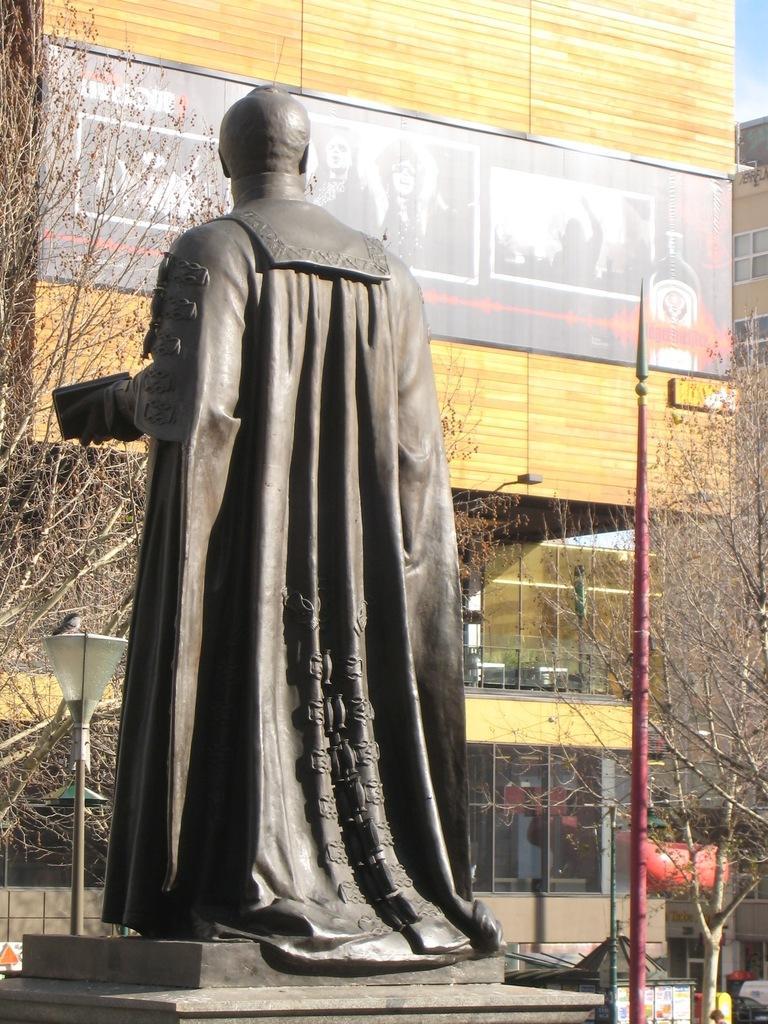Can you describe this image briefly? This picture shows a statue and we see couple of buildings and trees. We see a pole light and a blue cloudy Sky. 